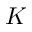<formula> <loc_0><loc_0><loc_500><loc_500>K</formula> 